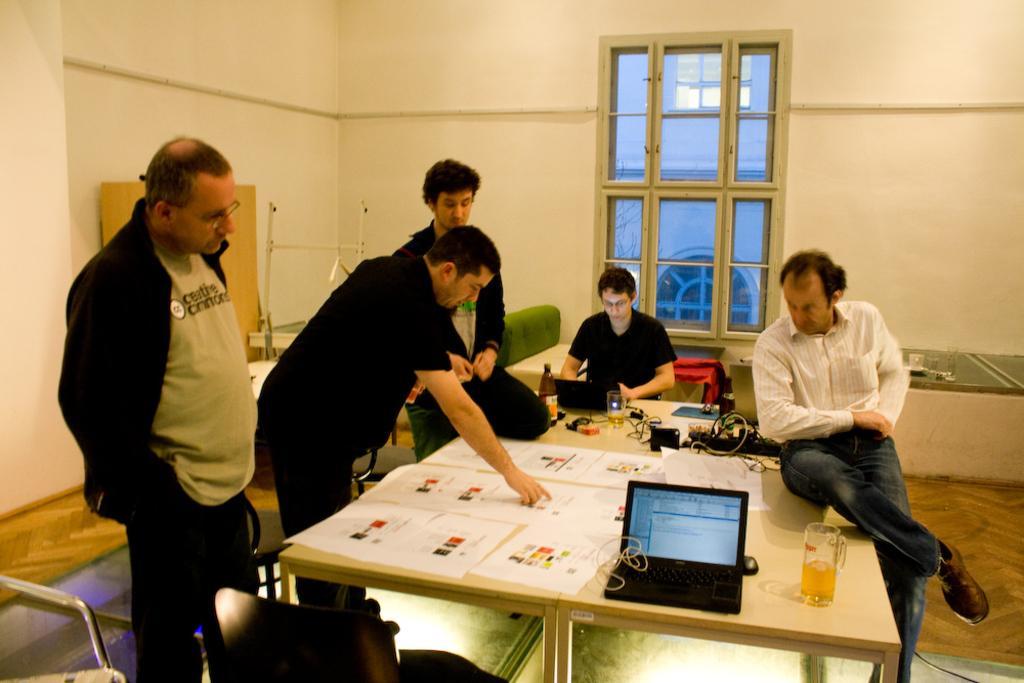Can you describe this image briefly? This picture shows a group of people Standing and sitting and have a table in front of them there is a laptop a bear glass and some papers and cables on it 